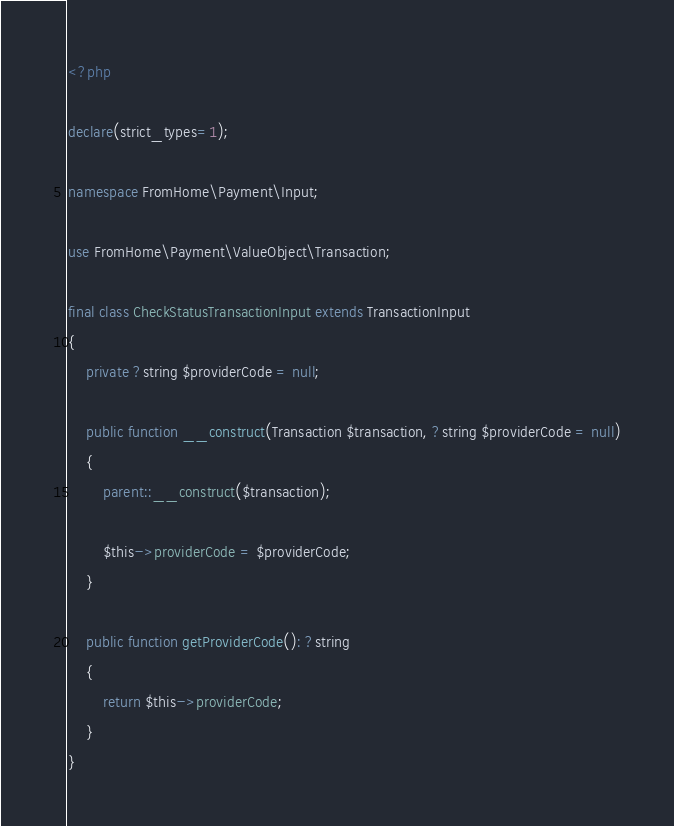Convert code to text. <code><loc_0><loc_0><loc_500><loc_500><_PHP_><?php

declare(strict_types=1);

namespace FromHome\Payment\Input;

use FromHome\Payment\ValueObject\Transaction;

final class CheckStatusTransactionInput extends TransactionInput
{
    private ?string $providerCode = null;

    public function __construct(Transaction $transaction, ?string $providerCode = null)
    {
        parent::__construct($transaction);

        $this->providerCode = $providerCode;
    }

    public function getProviderCode(): ?string
    {
        return $this->providerCode;
    }
}
</code> 